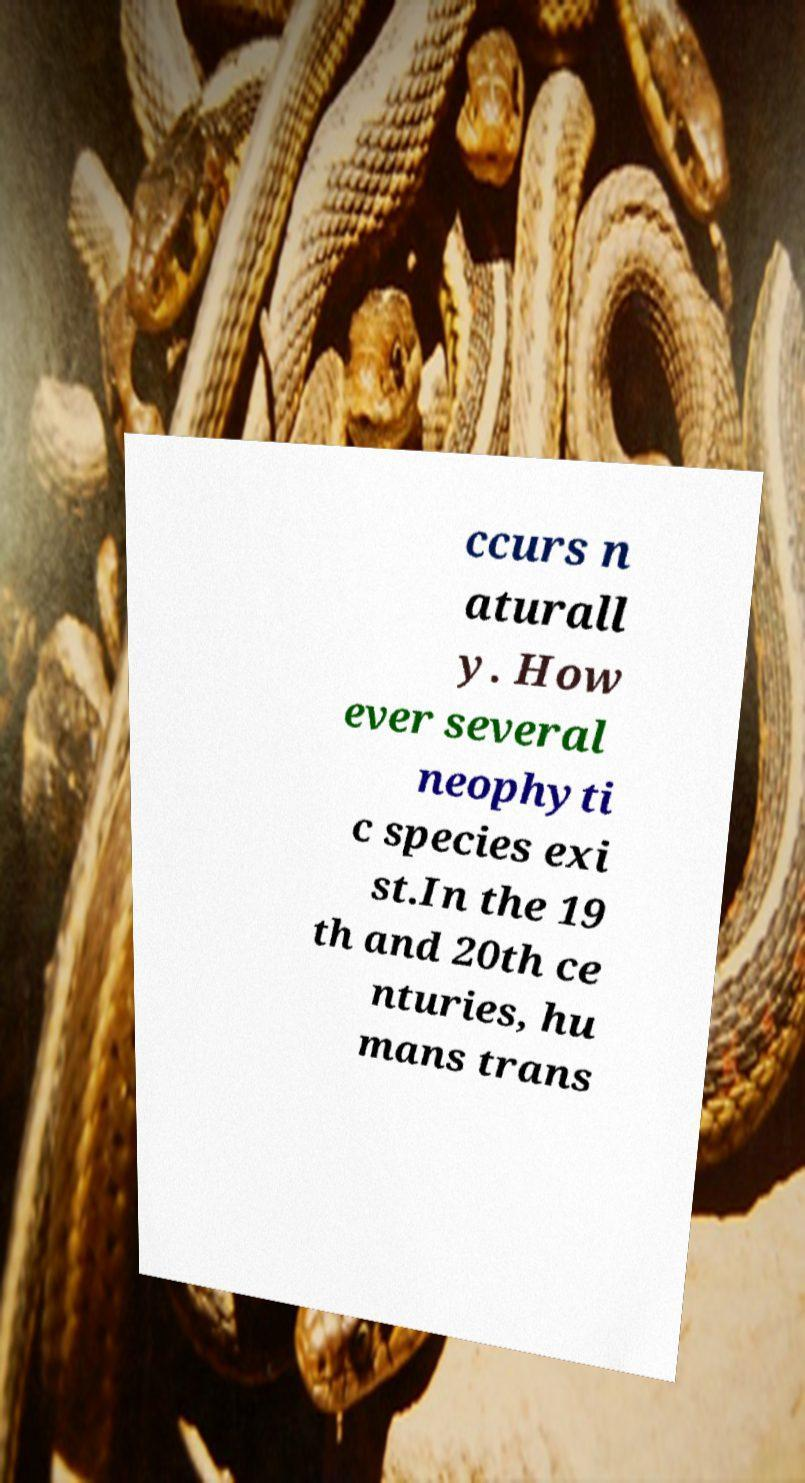Please read and relay the text visible in this image. What does it say? ccurs n aturall y. How ever several neophyti c species exi st.In the 19 th and 20th ce nturies, hu mans trans 